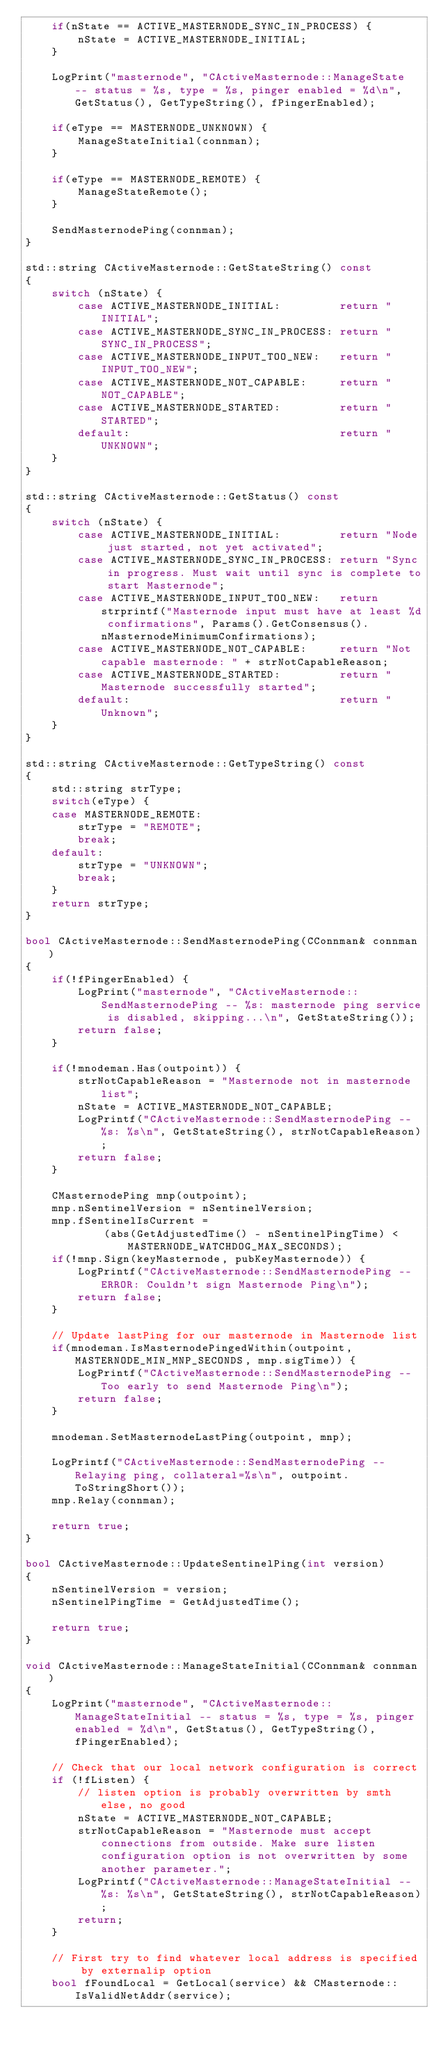Convert code to text. <code><loc_0><loc_0><loc_500><loc_500><_C++_>    if(nState == ACTIVE_MASTERNODE_SYNC_IN_PROCESS) {
        nState = ACTIVE_MASTERNODE_INITIAL;
    }

    LogPrint("masternode", "CActiveMasternode::ManageState -- status = %s, type = %s, pinger enabled = %d\n", GetStatus(), GetTypeString(), fPingerEnabled);

    if(eType == MASTERNODE_UNKNOWN) {
        ManageStateInitial(connman);
    }

    if(eType == MASTERNODE_REMOTE) {
        ManageStateRemote();
    }

    SendMasternodePing(connman);
}

std::string CActiveMasternode::GetStateString() const
{
    switch (nState) {
        case ACTIVE_MASTERNODE_INITIAL:         return "INITIAL";
        case ACTIVE_MASTERNODE_SYNC_IN_PROCESS: return "SYNC_IN_PROCESS";
        case ACTIVE_MASTERNODE_INPUT_TOO_NEW:   return "INPUT_TOO_NEW";
        case ACTIVE_MASTERNODE_NOT_CAPABLE:     return "NOT_CAPABLE";
        case ACTIVE_MASTERNODE_STARTED:         return "STARTED";
        default:                                return "UNKNOWN";
    }
}

std::string CActiveMasternode::GetStatus() const
{
    switch (nState) {
        case ACTIVE_MASTERNODE_INITIAL:         return "Node just started, not yet activated";
        case ACTIVE_MASTERNODE_SYNC_IN_PROCESS: return "Sync in progress. Must wait until sync is complete to start Masternode";
        case ACTIVE_MASTERNODE_INPUT_TOO_NEW:   return strprintf("Masternode input must have at least %d confirmations", Params().GetConsensus().nMasternodeMinimumConfirmations);
        case ACTIVE_MASTERNODE_NOT_CAPABLE:     return "Not capable masternode: " + strNotCapableReason;
        case ACTIVE_MASTERNODE_STARTED:         return "Masternode successfully started";
        default:                                return "Unknown";
    }
}

std::string CActiveMasternode::GetTypeString() const
{
    std::string strType;
    switch(eType) {
    case MASTERNODE_REMOTE:
        strType = "REMOTE";
        break;
    default:
        strType = "UNKNOWN";
        break;
    }
    return strType;
}

bool CActiveMasternode::SendMasternodePing(CConnman& connman)
{
    if(!fPingerEnabled) {
        LogPrint("masternode", "CActiveMasternode::SendMasternodePing -- %s: masternode ping service is disabled, skipping...\n", GetStateString());
        return false;
    }

    if(!mnodeman.Has(outpoint)) {
        strNotCapableReason = "Masternode not in masternode list";
        nState = ACTIVE_MASTERNODE_NOT_CAPABLE;
        LogPrintf("CActiveMasternode::SendMasternodePing -- %s: %s\n", GetStateString(), strNotCapableReason);
        return false;
    }

    CMasternodePing mnp(outpoint);
    mnp.nSentinelVersion = nSentinelVersion;
    mnp.fSentinelIsCurrent =
            (abs(GetAdjustedTime() - nSentinelPingTime) < MASTERNODE_WATCHDOG_MAX_SECONDS);
    if(!mnp.Sign(keyMasternode, pubKeyMasternode)) {
        LogPrintf("CActiveMasternode::SendMasternodePing -- ERROR: Couldn't sign Masternode Ping\n");
        return false;
    }

    // Update lastPing for our masternode in Masternode list
    if(mnodeman.IsMasternodePingedWithin(outpoint, MASTERNODE_MIN_MNP_SECONDS, mnp.sigTime)) {
        LogPrintf("CActiveMasternode::SendMasternodePing -- Too early to send Masternode Ping\n");
        return false;
    }

    mnodeman.SetMasternodeLastPing(outpoint, mnp);

    LogPrintf("CActiveMasternode::SendMasternodePing -- Relaying ping, collateral=%s\n", outpoint.ToStringShort());
    mnp.Relay(connman);

    return true;
}

bool CActiveMasternode::UpdateSentinelPing(int version)
{
    nSentinelVersion = version;
    nSentinelPingTime = GetAdjustedTime();

    return true;
}

void CActiveMasternode::ManageStateInitial(CConnman& connman)
{
    LogPrint("masternode", "CActiveMasternode::ManageStateInitial -- status = %s, type = %s, pinger enabled = %d\n", GetStatus(), GetTypeString(), fPingerEnabled);

    // Check that our local network configuration is correct
    if (!fListen) {
        // listen option is probably overwritten by smth else, no good
        nState = ACTIVE_MASTERNODE_NOT_CAPABLE;
        strNotCapableReason = "Masternode must accept connections from outside. Make sure listen configuration option is not overwritten by some another parameter.";
        LogPrintf("CActiveMasternode::ManageStateInitial -- %s: %s\n", GetStateString(), strNotCapableReason);
        return;
    }

    // First try to find whatever local address is specified by externalip option
    bool fFoundLocal = GetLocal(service) && CMasternode::IsValidNetAddr(service);</code> 